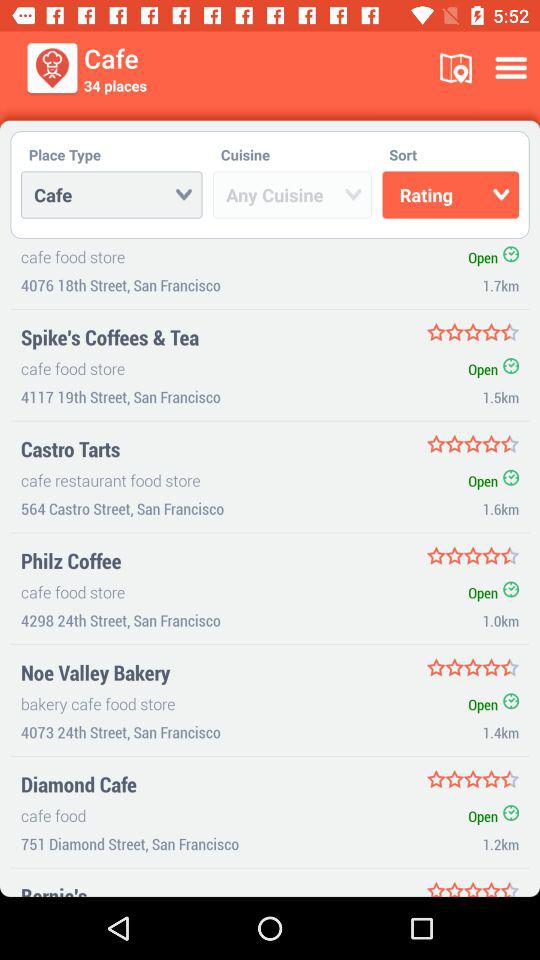What is the location of "Diamond Cafe"? The location is 751 Diamond Street, San Francisco. 